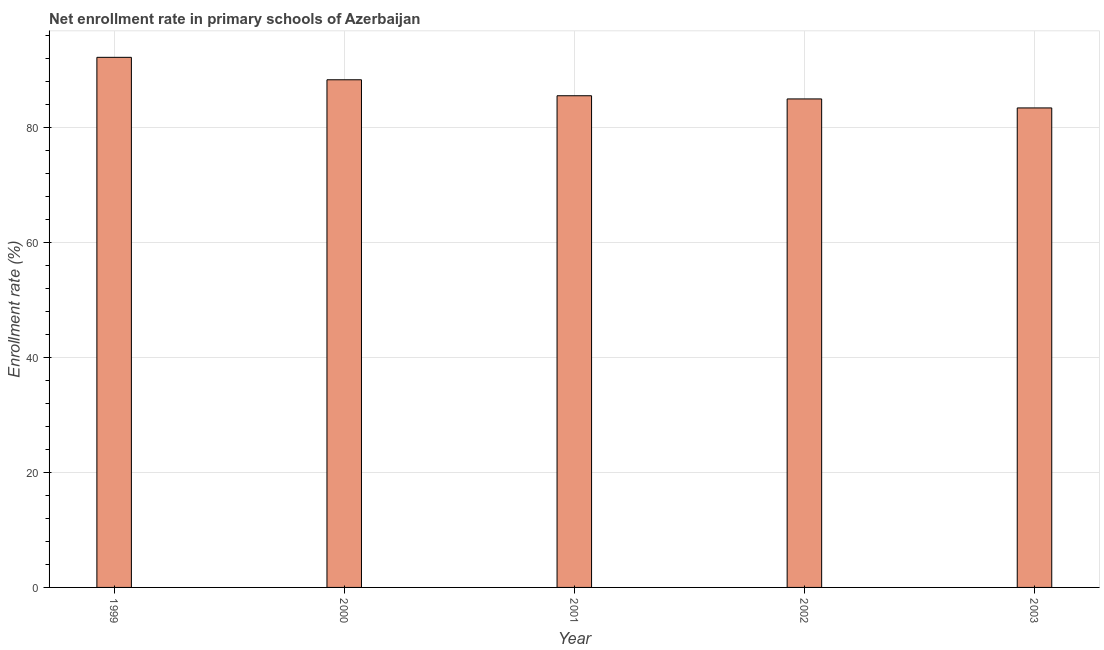Does the graph contain any zero values?
Your answer should be compact. No. What is the title of the graph?
Provide a short and direct response. Net enrollment rate in primary schools of Azerbaijan. What is the label or title of the Y-axis?
Your answer should be very brief. Enrollment rate (%). What is the net enrollment rate in primary schools in 2002?
Ensure brevity in your answer.  84.91. Across all years, what is the maximum net enrollment rate in primary schools?
Keep it short and to the point. 92.14. Across all years, what is the minimum net enrollment rate in primary schools?
Give a very brief answer. 83.35. What is the sum of the net enrollment rate in primary schools?
Keep it short and to the point. 434.1. What is the difference between the net enrollment rate in primary schools in 2000 and 2001?
Keep it short and to the point. 2.78. What is the average net enrollment rate in primary schools per year?
Make the answer very short. 86.82. What is the median net enrollment rate in primary schools?
Your answer should be compact. 85.46. In how many years, is the net enrollment rate in primary schools greater than 8 %?
Make the answer very short. 5. Do a majority of the years between 2003 and 2000 (inclusive) have net enrollment rate in primary schools greater than 60 %?
Your response must be concise. Yes. What is the ratio of the net enrollment rate in primary schools in 1999 to that in 2002?
Offer a very short reply. 1.08. Is the net enrollment rate in primary schools in 2000 less than that in 2002?
Your answer should be very brief. No. Is the difference between the net enrollment rate in primary schools in 2000 and 2003 greater than the difference between any two years?
Provide a short and direct response. No. What is the difference between the highest and the second highest net enrollment rate in primary schools?
Keep it short and to the point. 3.9. What is the difference between the highest and the lowest net enrollment rate in primary schools?
Make the answer very short. 8.79. In how many years, is the net enrollment rate in primary schools greater than the average net enrollment rate in primary schools taken over all years?
Your answer should be compact. 2. How many bars are there?
Your response must be concise. 5. What is the Enrollment rate (%) of 1999?
Offer a very short reply. 92.14. What is the Enrollment rate (%) of 2000?
Keep it short and to the point. 88.24. What is the Enrollment rate (%) of 2001?
Your answer should be very brief. 85.46. What is the Enrollment rate (%) in 2002?
Offer a very short reply. 84.91. What is the Enrollment rate (%) of 2003?
Offer a terse response. 83.35. What is the difference between the Enrollment rate (%) in 1999 and 2000?
Keep it short and to the point. 3.9. What is the difference between the Enrollment rate (%) in 1999 and 2001?
Your answer should be compact. 6.68. What is the difference between the Enrollment rate (%) in 1999 and 2002?
Give a very brief answer. 7.23. What is the difference between the Enrollment rate (%) in 1999 and 2003?
Make the answer very short. 8.79. What is the difference between the Enrollment rate (%) in 2000 and 2001?
Offer a very short reply. 2.78. What is the difference between the Enrollment rate (%) in 2000 and 2002?
Offer a very short reply. 3.33. What is the difference between the Enrollment rate (%) in 2000 and 2003?
Offer a very short reply. 4.89. What is the difference between the Enrollment rate (%) in 2001 and 2002?
Provide a short and direct response. 0.55. What is the difference between the Enrollment rate (%) in 2001 and 2003?
Give a very brief answer. 2.12. What is the difference between the Enrollment rate (%) in 2002 and 2003?
Ensure brevity in your answer.  1.56. What is the ratio of the Enrollment rate (%) in 1999 to that in 2000?
Your response must be concise. 1.04. What is the ratio of the Enrollment rate (%) in 1999 to that in 2001?
Provide a succinct answer. 1.08. What is the ratio of the Enrollment rate (%) in 1999 to that in 2002?
Offer a terse response. 1.08. What is the ratio of the Enrollment rate (%) in 1999 to that in 2003?
Your response must be concise. 1.11. What is the ratio of the Enrollment rate (%) in 2000 to that in 2001?
Ensure brevity in your answer.  1.03. What is the ratio of the Enrollment rate (%) in 2000 to that in 2002?
Give a very brief answer. 1.04. What is the ratio of the Enrollment rate (%) in 2000 to that in 2003?
Offer a very short reply. 1.06. What is the ratio of the Enrollment rate (%) in 2001 to that in 2003?
Ensure brevity in your answer.  1.02. What is the ratio of the Enrollment rate (%) in 2002 to that in 2003?
Offer a very short reply. 1.02. 